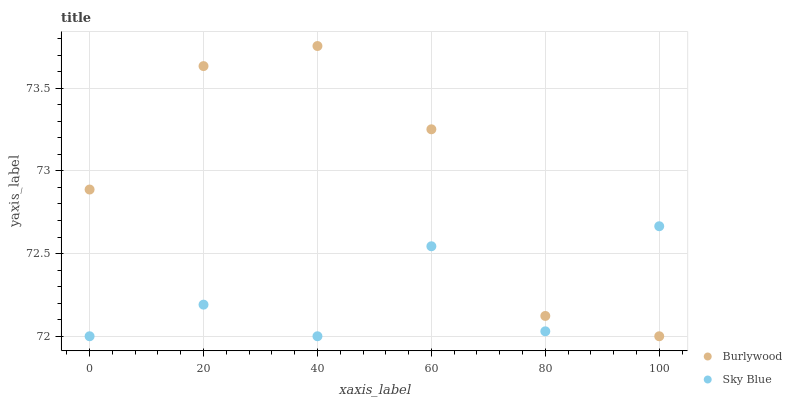Does Sky Blue have the minimum area under the curve?
Answer yes or no. Yes. Does Burlywood have the maximum area under the curve?
Answer yes or no. Yes. Does Sky Blue have the maximum area under the curve?
Answer yes or no. No. Is Burlywood the smoothest?
Answer yes or no. Yes. Is Sky Blue the roughest?
Answer yes or no. Yes. Is Sky Blue the smoothest?
Answer yes or no. No. Does Burlywood have the lowest value?
Answer yes or no. Yes. Does Burlywood have the highest value?
Answer yes or no. Yes. Does Sky Blue have the highest value?
Answer yes or no. No. Does Burlywood intersect Sky Blue?
Answer yes or no. Yes. Is Burlywood less than Sky Blue?
Answer yes or no. No. Is Burlywood greater than Sky Blue?
Answer yes or no. No. 